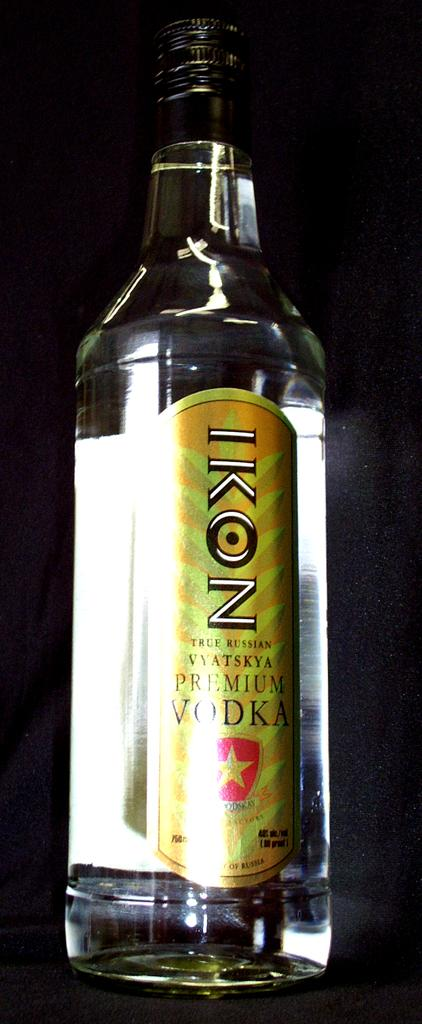What is the main object in the image? There is a vodka bottle in the image. Where is the vodka bottle located? The vodka bottle is on a table. How does the cat contribute to world peace in the image? There is no cat present in the image, so it cannot contribute to world peace in this context. 